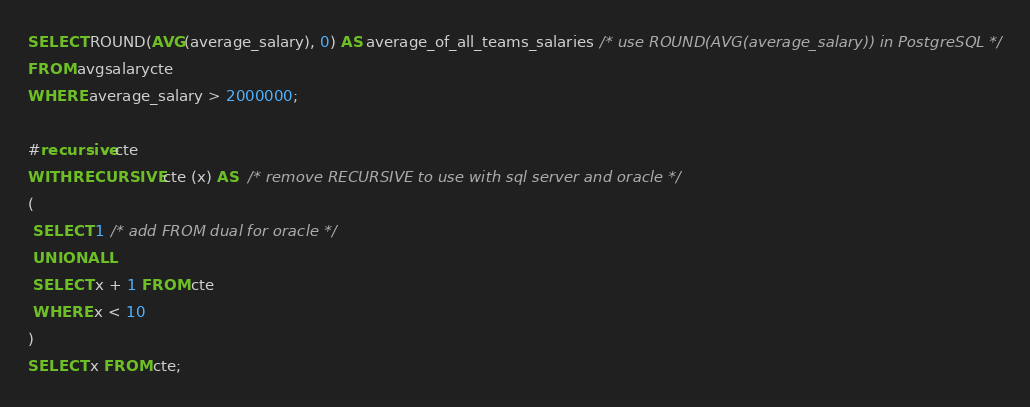Convert code to text. <code><loc_0><loc_0><loc_500><loc_500><_SQL_>
SELECT ROUND(AVG(average_salary), 0) AS average_of_all_teams_salaries /* use ROUND(AVG(average_salary)) in PostgreSQL */
FROM avgsalarycte
WHERE average_salary > 2000000;

#recursive cte
WITH RECURSIVE cte (x) AS  /* remove RECURSIVE to use with sql server and oracle */
(
 SELECT 1 /* add FROM dual for oracle */ 
 UNION ALL 
 SELECT x + 1 FROM cte
 WHERE x < 10
)
SELECT x FROM cte;</code> 